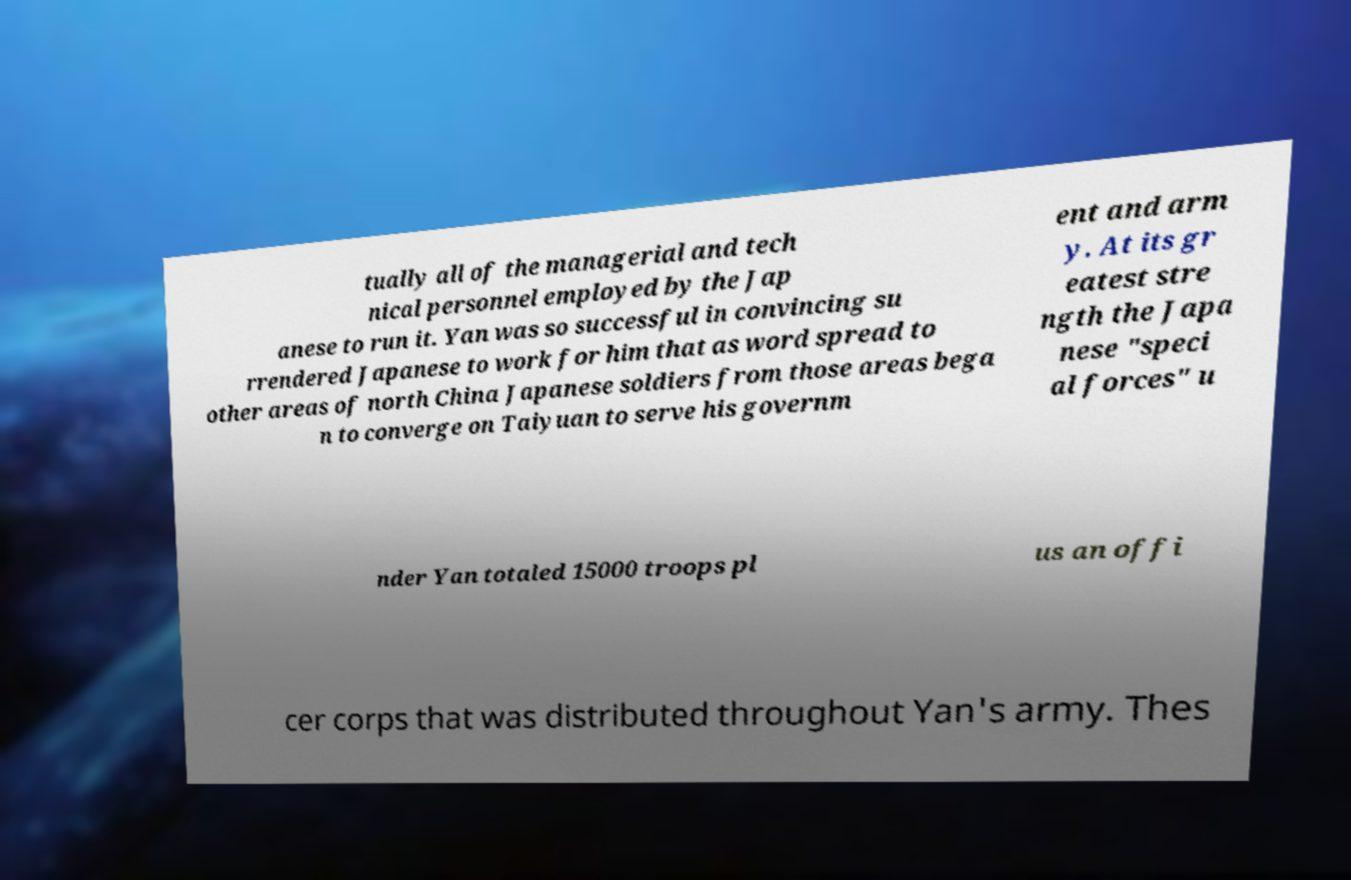Could you assist in decoding the text presented in this image and type it out clearly? tually all of the managerial and tech nical personnel employed by the Jap anese to run it. Yan was so successful in convincing su rrendered Japanese to work for him that as word spread to other areas of north China Japanese soldiers from those areas bega n to converge on Taiyuan to serve his governm ent and arm y. At its gr eatest stre ngth the Japa nese "speci al forces" u nder Yan totaled 15000 troops pl us an offi cer corps that was distributed throughout Yan's army. Thes 